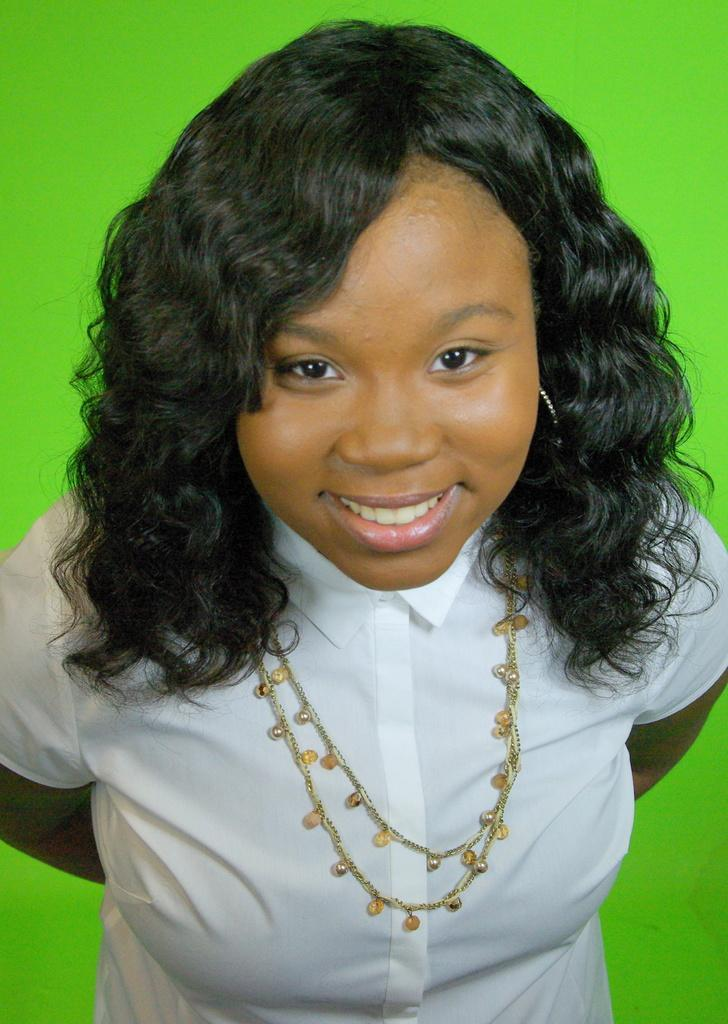Who is the main subject in the image? There is a woman in the image. What is the woman doing in the image? The woman is smiling. What is the woman wearing in the image? The woman is wearing a white dress. What accessory is the woman wearing in the image? The woman has a chain around her neck. What can be seen in the background of the image? The background of the image is green. What type of decision is the woman making in the image? There is no indication in the image that the woman is making a decision. What is the woman's current financial situation based on the image? There is no information about the woman's financial situation in the image. 